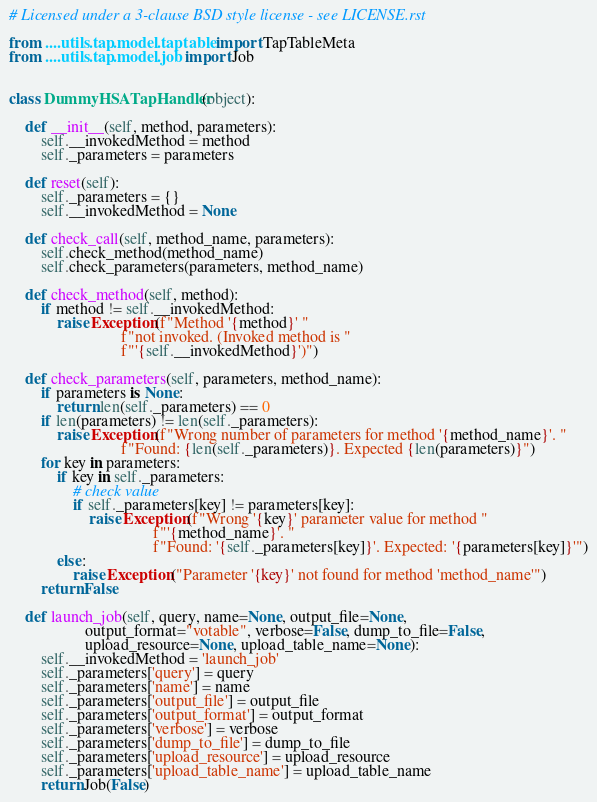<code> <loc_0><loc_0><loc_500><loc_500><_Python_># Licensed under a 3-clause BSD style license - see LICENSE.rst

from ....utils.tap.model.taptable import TapTableMeta
from ....utils.tap.model.job import Job


class DummyHSATapHandler(object):

    def __init__(self, method, parameters):
        self.__invokedMethod = method
        self._parameters = parameters

    def reset(self):
        self._parameters = {}
        self.__invokedMethod = None

    def check_call(self, method_name, parameters):
        self.check_method(method_name)
        self.check_parameters(parameters, method_name)

    def check_method(self, method):
        if method != self.__invokedMethod:
            raise Exception(f"Method '{method}' "
                            f"not invoked. (Invoked method is "
                            f"'{self.__invokedMethod}')")

    def check_parameters(self, parameters, method_name):
        if parameters is None:
            return len(self._parameters) == 0
        if len(parameters) != len(self._parameters):
            raise Exception(f"Wrong number of parameters for method '{method_name}'. "
                            f"Found: {len(self._parameters)}. Expected {len(parameters)}")
        for key in parameters:
            if key in self._parameters:
                # check value
                if self._parameters[key] != parameters[key]:
                    raise Exception(f"Wrong '{key}' parameter value for method "
                                    f"'{method_name}'. "
                                    f"Found: '{self._parameters[key]}'. Expected: '{parameters[key]}'")
            else:
                raise Exception("Parameter '{key}' not found for method 'method_name'")
        return False

    def launch_job(self, query, name=None, output_file=None,
                   output_format="votable", verbose=False, dump_to_file=False,
                   upload_resource=None, upload_table_name=None):
        self.__invokedMethod = 'launch_job'
        self._parameters['query'] = query
        self._parameters['name'] = name
        self._parameters['output_file'] = output_file
        self._parameters['output_format'] = output_format
        self._parameters['verbose'] = verbose
        self._parameters['dump_to_file'] = dump_to_file
        self._parameters['upload_resource'] = upload_resource
        self._parameters['upload_table_name'] = upload_table_name
        return Job(False)
</code> 